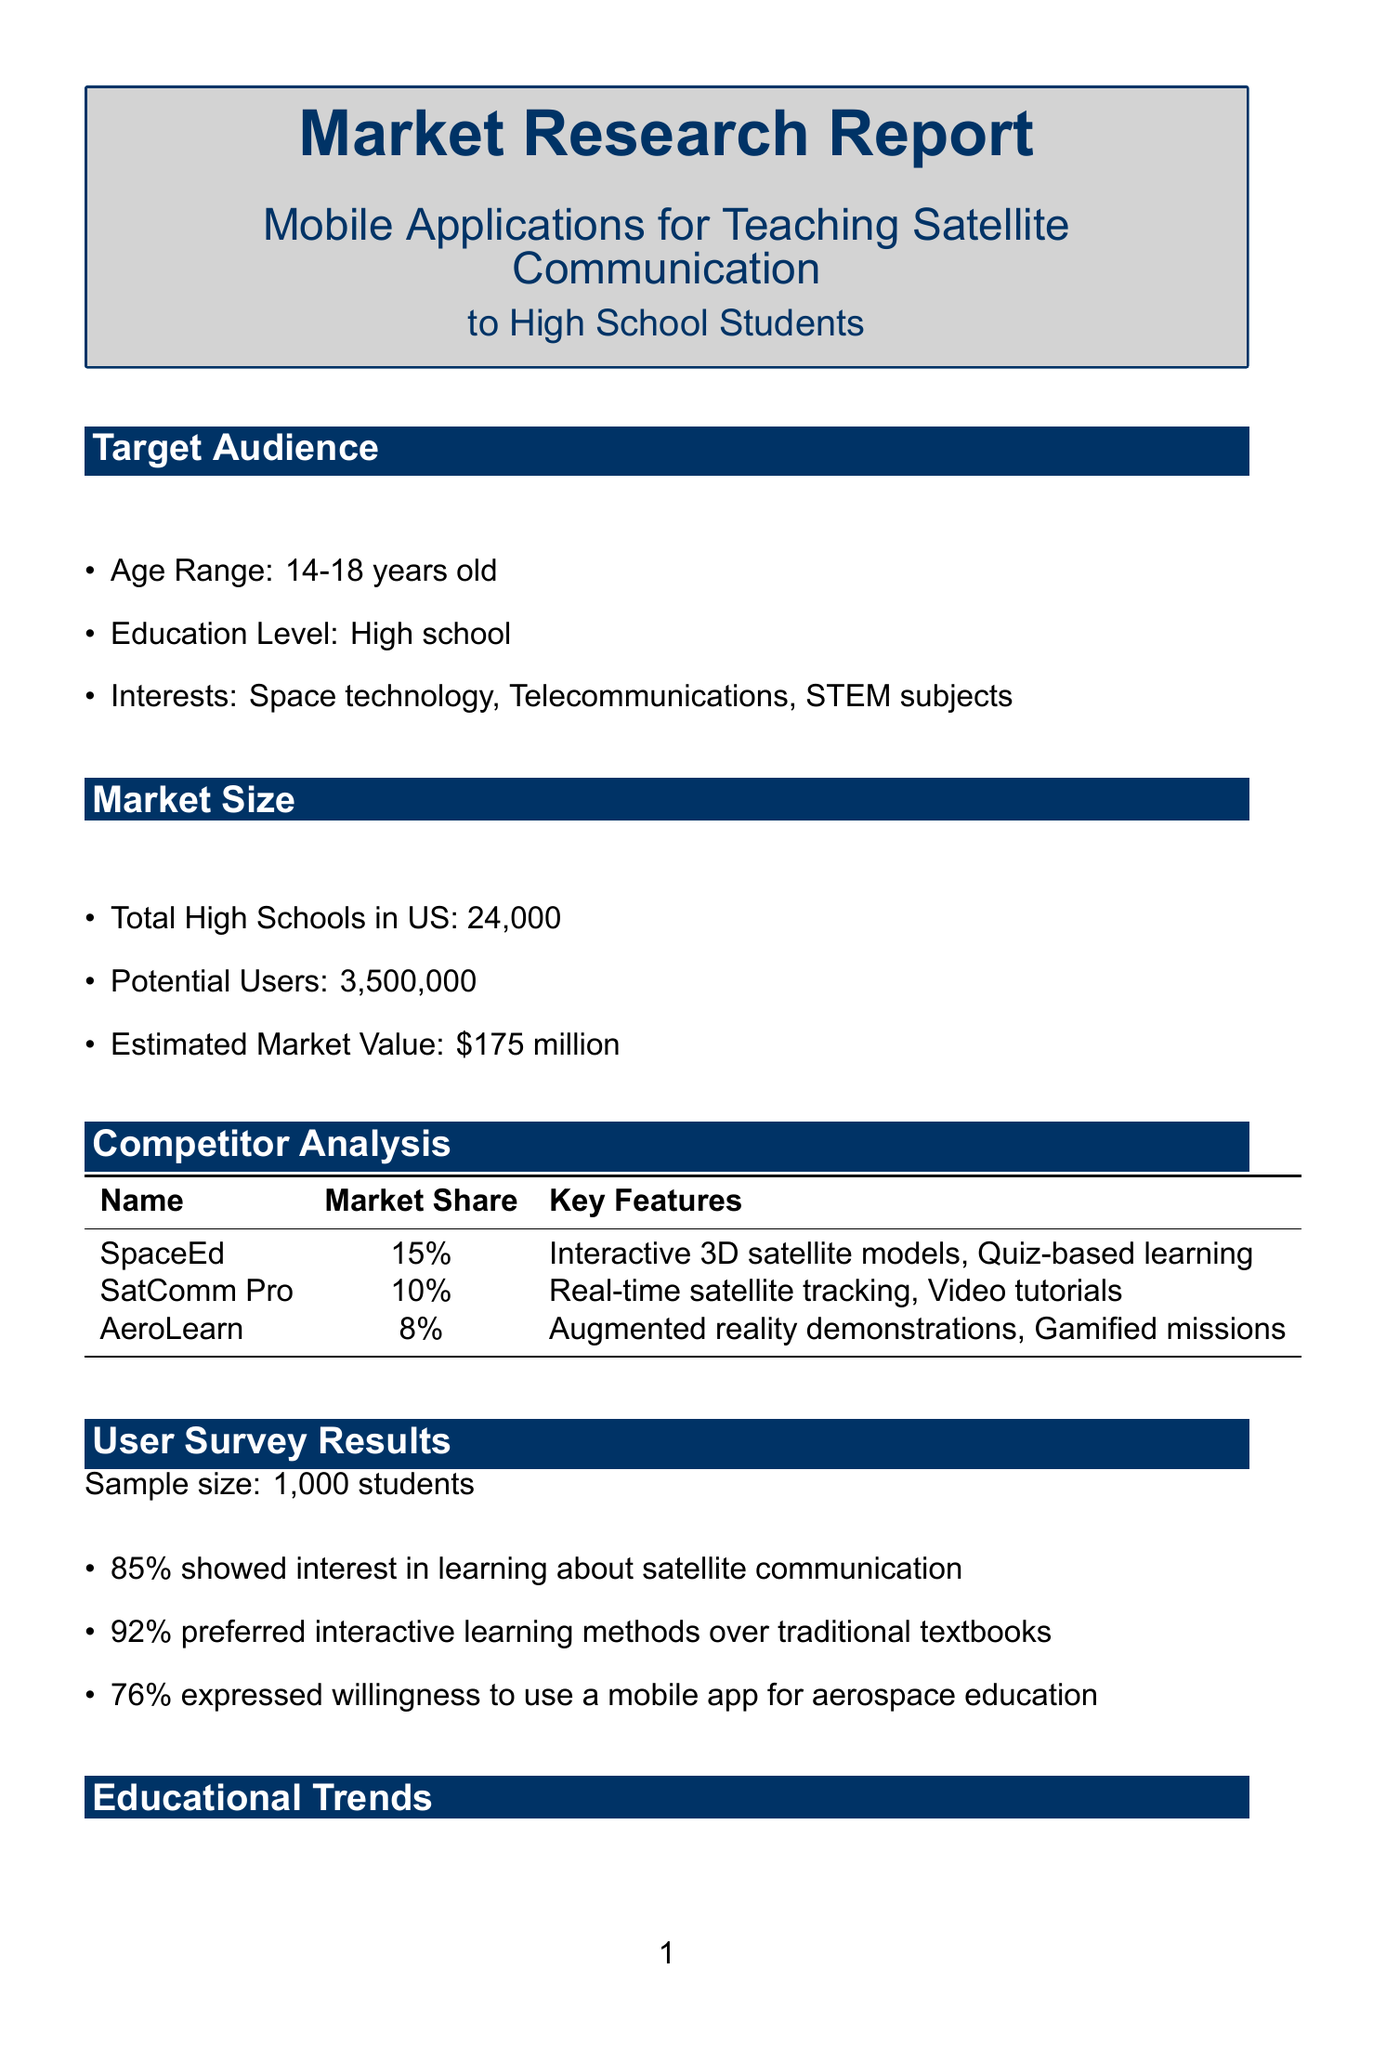What is the age range of the target audience? The document states that the target audience is between 14-18 years old.
Answer: 14-18 years old How many total high schools are there in the US? The document lists the total number of high schools in the US as 24,000.
Answer: 24,000 What percentage of students prefer interactive learning methods? According to the user survey results, 92% of students prefer interactive learning methods.
Answer: 92% Name a competitor with a market share of 15%. The document lists SpaceEd as a competitor with a market share of 15%.
Answer: SpaceEd What is a potential challenge mentioned in the report? One of the challenges noted is ensuring content aligns with various state education standards.
Answer: Ensuring content aligns with various state education standards Which organization is suggested as a potential partner for curriculum integration? The report suggests the National Science Teachers Association for curriculum integration and teacher training.
Answer: National Science Teachers Association What is one key feature required for the technology? The key features include offline mode for limited connectivity areas.
Answer: Offline mode for limited connectivity areas What pricing model involves an annual subscription based on the number of students? The school license pricing model is based on an annual subscription contingent on the number of students.
Answer: School license What is the estimated market value for mobile applications in this sector? The estimated market value mentioned in the report is $175 million.
Answer: $175 million 